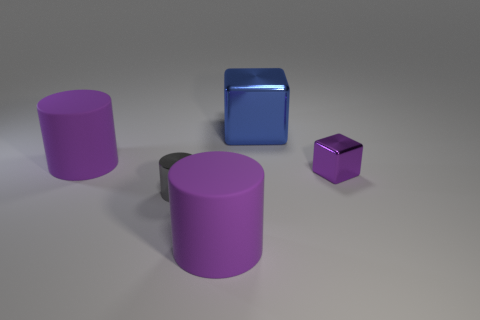Is the size of the blue metal cube the same as the metallic thing that is to the left of the big metallic cube? No, the size of the blue metal cube is not the same as the smaller, purple metallic cylinder to the left of the larger metallic cube. The blue cube appears to be a medium-sized object in comparison to the other shapes around it, whereas the purple cylinder is notably larger in size. 